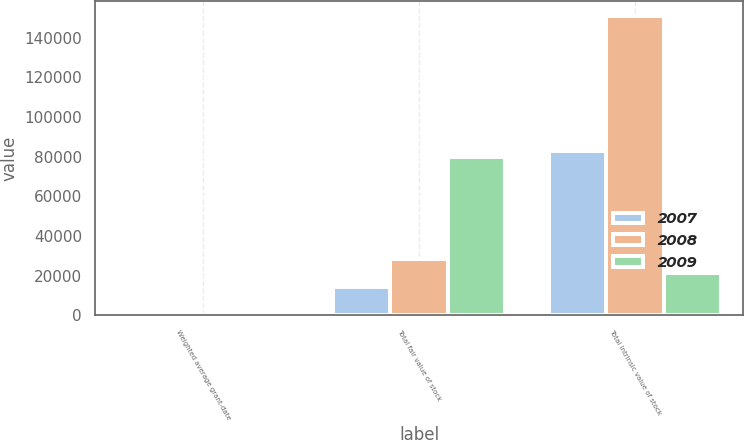<chart> <loc_0><loc_0><loc_500><loc_500><stacked_bar_chart><ecel><fcel>Weighted average grant-date<fcel>Total fair value of stock<fcel>Total intrinsic value of stock<nl><fcel>2007<fcel>12.54<fcel>14506<fcel>83089<nl><fcel>2008<fcel>15.51<fcel>28483<fcel>150711<nl><fcel>2009<fcel>14.15<fcel>79730<fcel>21494.5<nl></chart> 